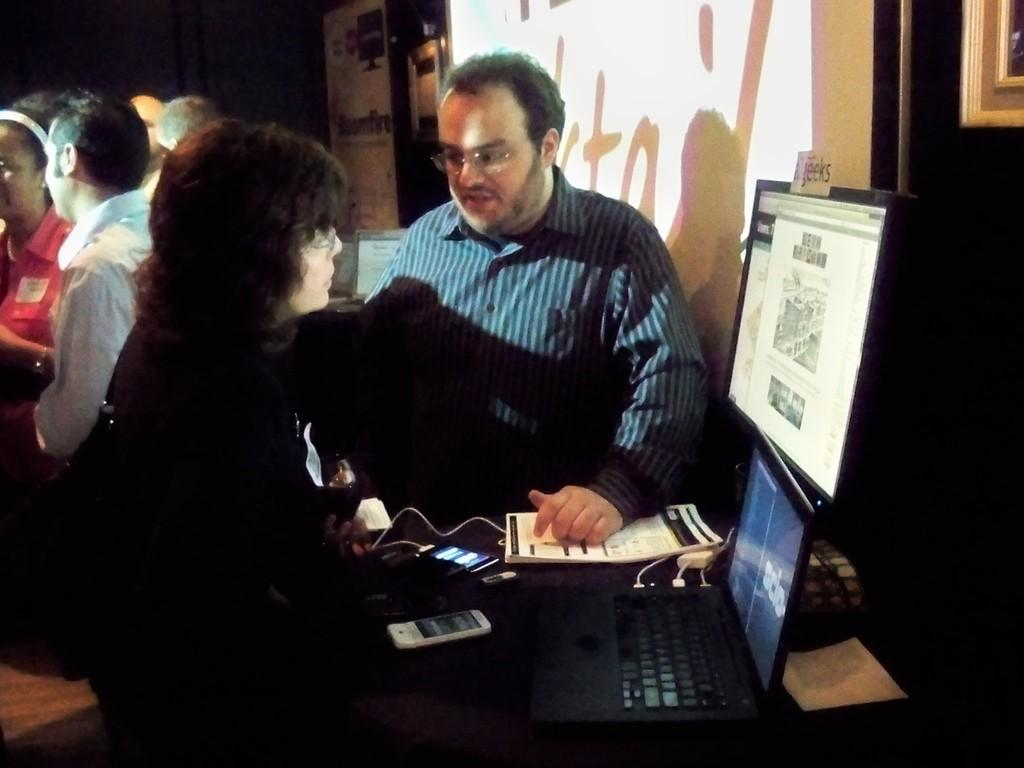Who or what can be seen in the image? There are people in the image. What is the background of the image? There is a wall in the image. Are there any objects on the wall? There is a photo frame in the image. What furniture is present in the image? There is a table in the image. What is on the table? There are screens, a mobile phone, and a book on the table. Can you see a yoke in the image? There is no yoke present in the image. What type of pencil is being used by the people in the image? There is no pencil visible in the image. 